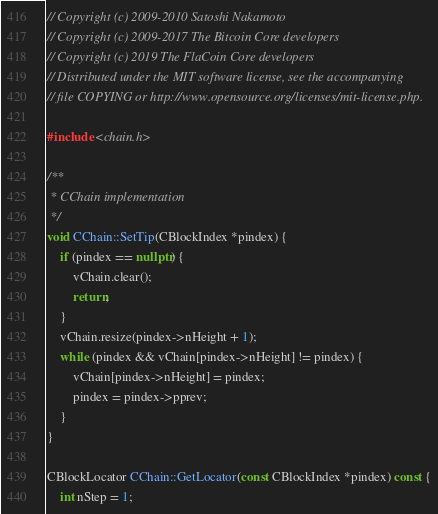Convert code to text. <code><loc_0><loc_0><loc_500><loc_500><_C++_>// Copyright (c) 2009-2010 Satoshi Nakamoto
// Copyright (c) 2009-2017 The Bitcoin Core developers
// Copyright (c) 2019 The FlaCoin Core developers
// Distributed under the MIT software license, see the accompanying
// file COPYING or http://www.opensource.org/licenses/mit-license.php.

#include <chain.h>

/**
 * CChain implementation
 */
void CChain::SetTip(CBlockIndex *pindex) {
    if (pindex == nullptr) {
        vChain.clear();
        return;
    }
    vChain.resize(pindex->nHeight + 1);
    while (pindex && vChain[pindex->nHeight] != pindex) {
        vChain[pindex->nHeight] = pindex;
        pindex = pindex->pprev;
    }
}

CBlockLocator CChain::GetLocator(const CBlockIndex *pindex) const {
    int nStep = 1;</code> 